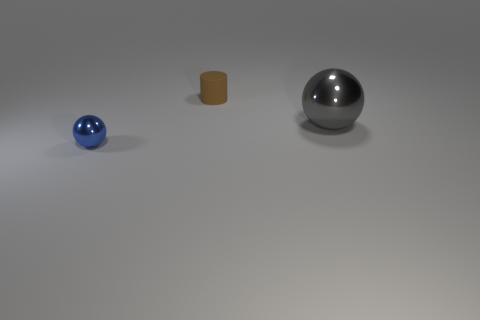There is a metal ball in front of the gray object; is its size the same as the brown thing?
Keep it short and to the point. Yes. How many objects are either small matte cylinders behind the large metallic thing or purple cylinders?
Your response must be concise. 1. Are there any green metal things that have the same size as the brown cylinder?
Ensure brevity in your answer.  No. What is the material of the thing that is the same size as the blue metallic sphere?
Your answer should be very brief. Rubber. There is a thing that is in front of the brown object and right of the blue metallic thing; what is its shape?
Keep it short and to the point. Sphere. There is a shiny sphere that is in front of the large object; what color is it?
Offer a very short reply. Blue. There is a thing that is behind the blue object and in front of the small brown rubber cylinder; what size is it?
Offer a terse response. Large. Does the gray object have the same material as the ball that is in front of the gray ball?
Provide a succinct answer. Yes. What number of other rubber objects are the same shape as the gray thing?
Keep it short and to the point. 0. What number of objects are there?
Give a very brief answer. 3. 